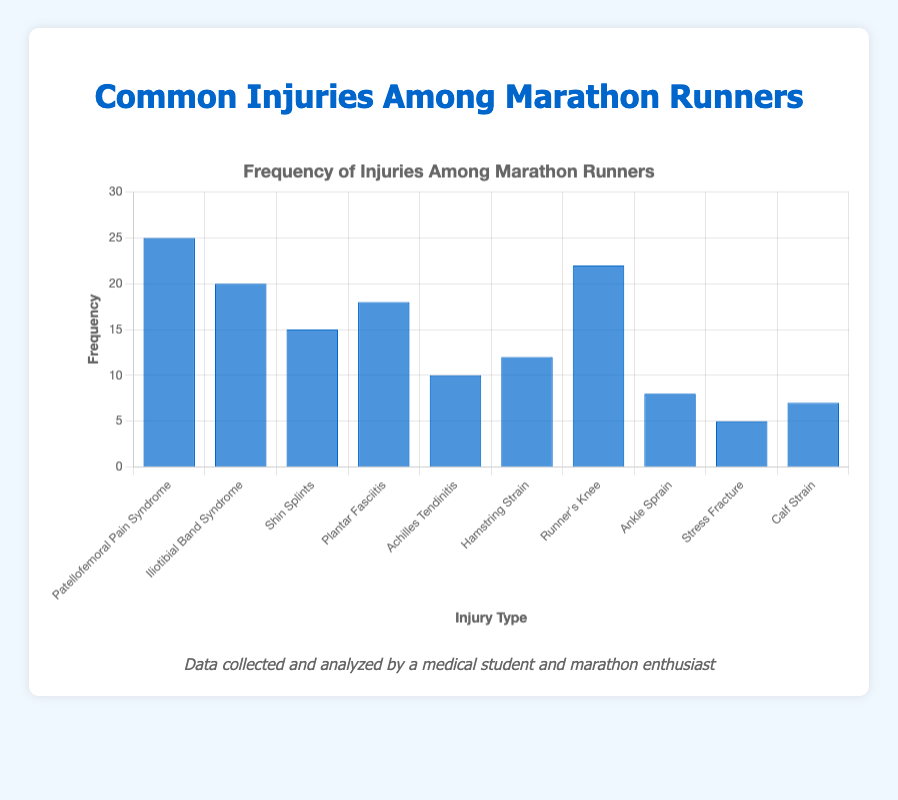What injury has the highest frequency? The bar representing "Patellofemoral Pain Syndrome" is the tallest, indicating the highest frequency.
Answer: Patellofemoral Pain Syndrome What is the total frequency of "Shin Splints" and "Plantar Fasciitis"? The frequency of "Shin Splints" is 15 and "Plantar Fasciitis" is 18. Adding them together gives 15 + 18 = 33.
Answer: 33 What injury occurs more frequently, "Runner's Knee" or "Hamstring Strain"? By comparing the height of the bars, "Runner's Knee" has a frequency of 22, which is greater than "Hamstring Strain" with a frequency of 12.
Answer: Runner's Knee How much more frequent is "Iliotibial Band Syndrome" compared to "Achilles Tendinitis"? The frequency of "Iliotibial Band Syndrome" is 20, and the frequency of "Achilles Tendinitis" is 10. The difference is 20 - 10 = 10.
Answer: 10 What is the average frequency of the top three most common injuries? The frequencies of the top three injuries are: "Patellofemoral Pain Syndrome" (25), "Runner's Knee" (22), and "Iliotibial Band Syndrome" (20). The sum is 25 + 22 + 20 = 67. The average is 67 / 3 = 22.33.
Answer: 22.33 Which injury type has the lowest frequency? The shortest bar represents "Stress Fracture" with a frequency of 5.
Answer: Stress Fracture What is the combined frequency of "Achilles Tendinitis", "Ankle Sprain", and "Calf Strain"? The frequencies are: "Achilles Tendinitis" (10), "Ankle Sprain" (8), and "Calf Strain" (7). Their combined frequency is 10 + 8 + 7 = 25.
Answer: 25 If you add the frequency of "Hamstring Strain" and subtract the frequency of "Ankle Sprain", what is the result? "Hamstring Strain" has a frequency of 12 and "Ankle Sprain" has a frequency of 8. The result is 12 - 8 = 4.
Answer: 4 What is the median frequency of all the injuries listed? To find the median, list the frequencies in ascending order: 5, 7, 8, 10, 12, 15, 18, 20, 22, 25. The median is the average of the 5th and 6th values: (12 + 15) / 2 = 13.5.
Answer: 13.5 